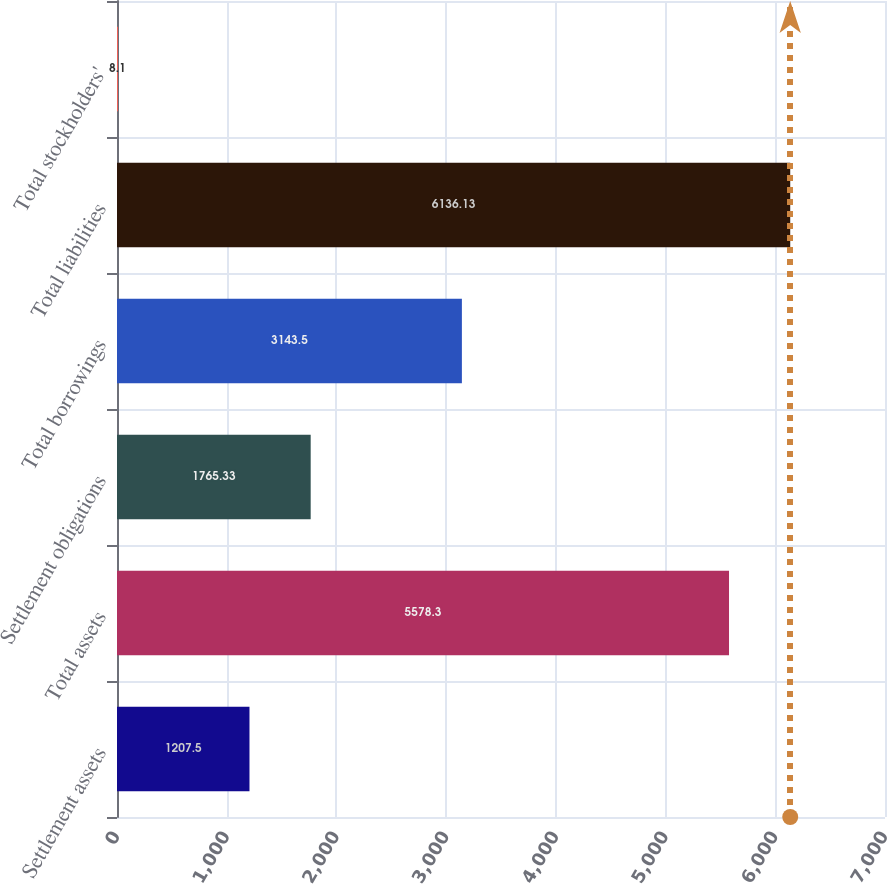Convert chart. <chart><loc_0><loc_0><loc_500><loc_500><bar_chart><fcel>Settlement assets<fcel>Total assets<fcel>Settlement obligations<fcel>Total borrowings<fcel>Total liabilities<fcel>Total stockholders'<nl><fcel>1207.5<fcel>5578.3<fcel>1765.33<fcel>3143.5<fcel>6136.13<fcel>8.1<nl></chart> 